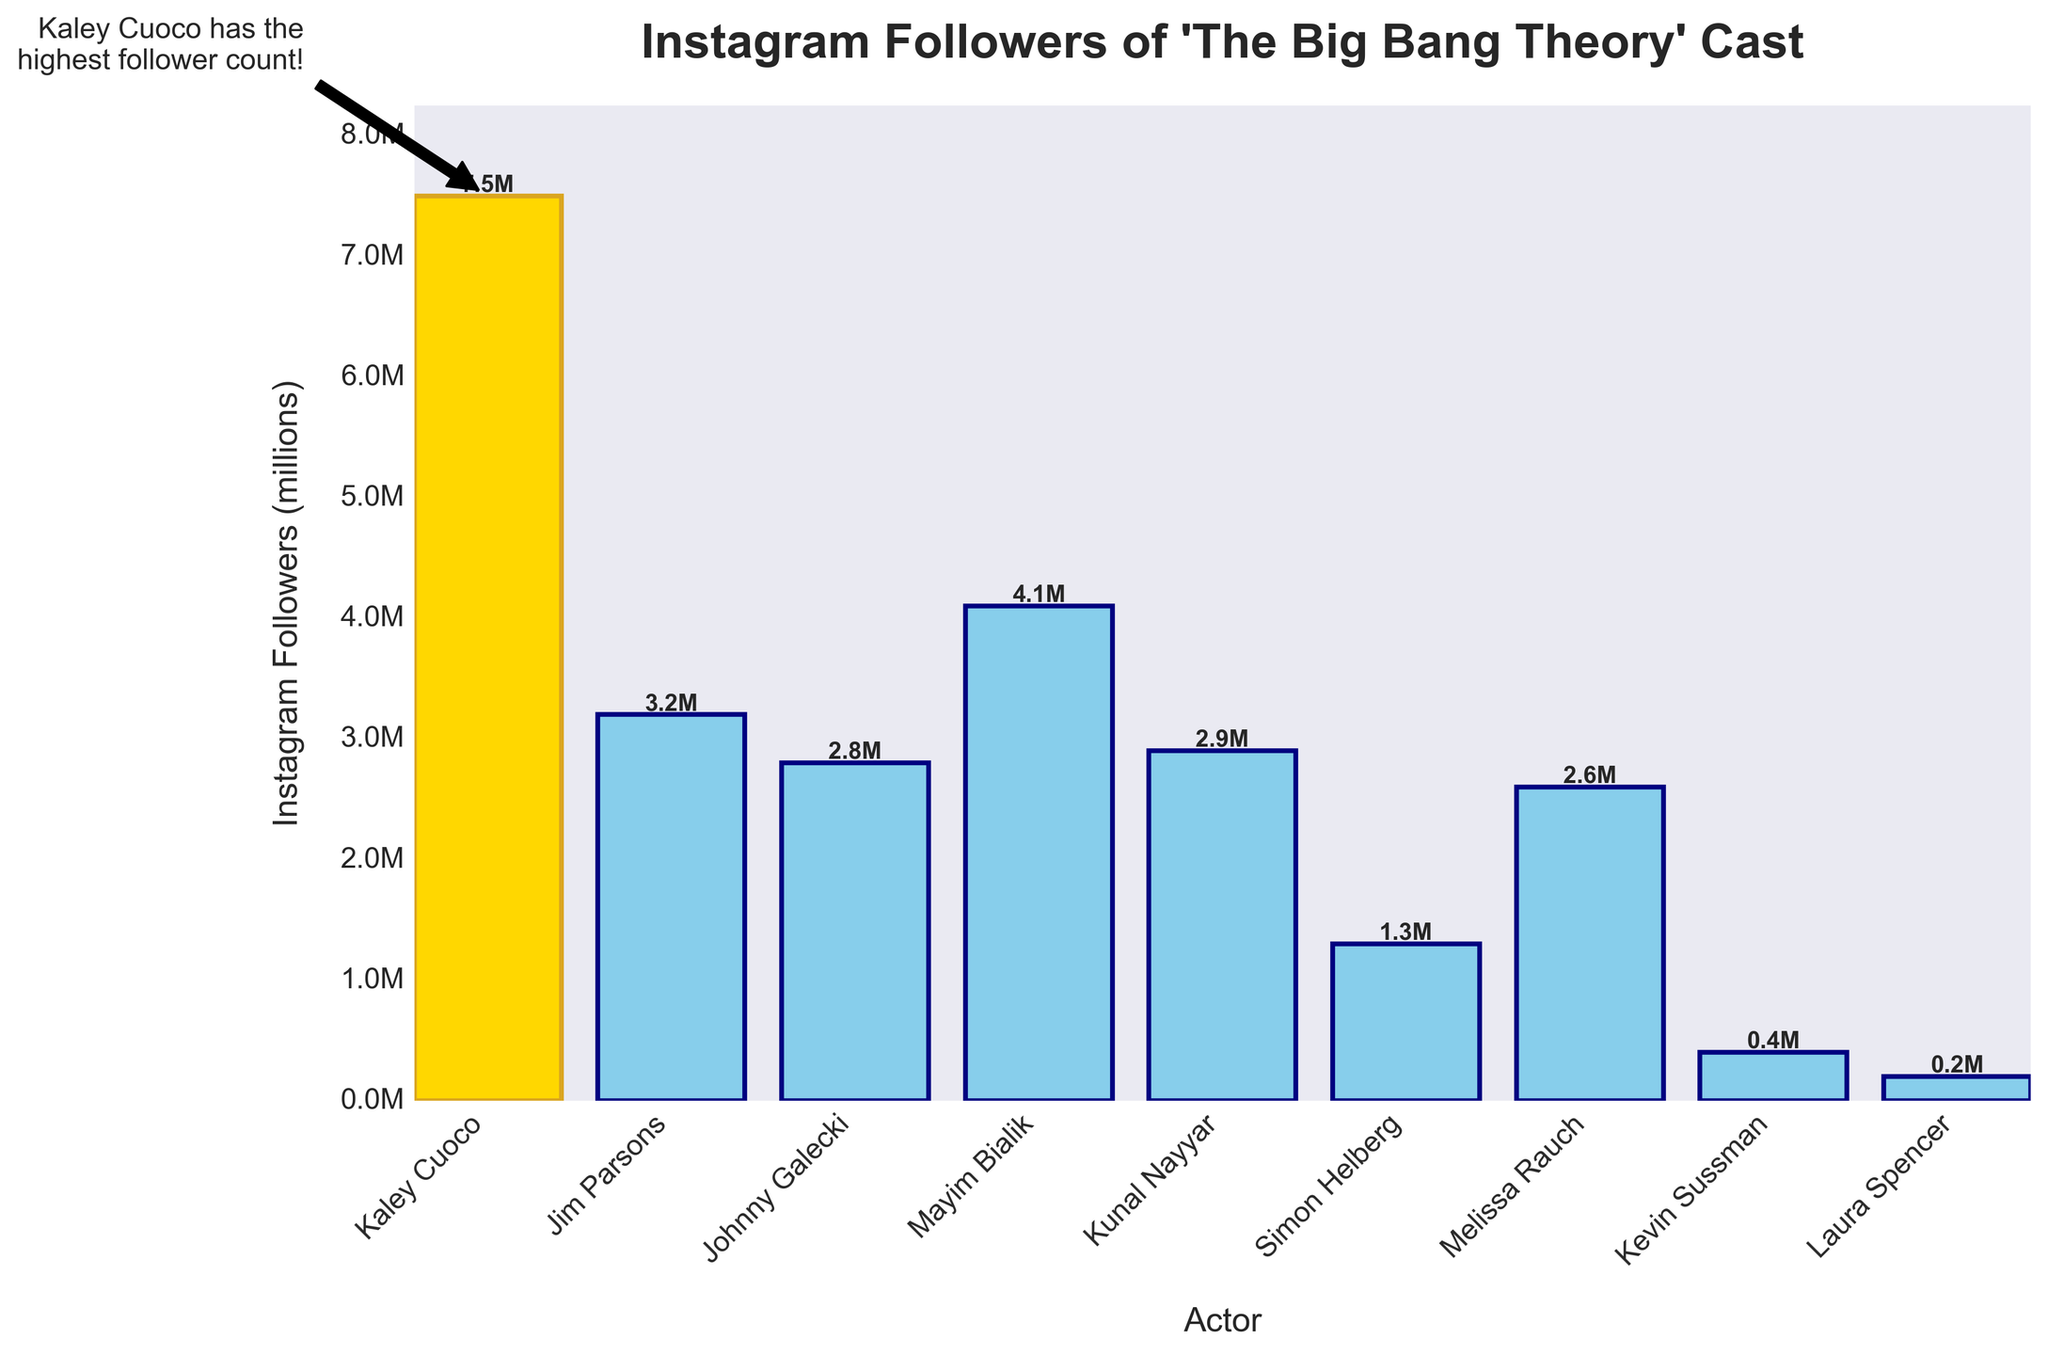Who is the actor with the highest Instagram follower count? Kaley Cuoco's bar is highlighted in gold and annotated with a note stating she has the highest follower count.
Answer: Kaley Cuoco Who has more followers, Jim Parsons or Kunal Nayyar? Jim Parsons has 3.2M followers and Kunal Nayyar has 2.9M followers; 3.2M is greater than 2.9M.
Answer: Jim Parsons What is the total Instagram follower count for Simon Helberg and Melissa Rauch? Simon Helberg has 1.3M followers and Melissa Rauch has 2.6M followers. Adding them together gives 1.3M + 2.6M = 3.9M.
Answer: 3.9M Which actor has fewer Instagram followers, Kevin Sussman or Laura Spencer? Kevin Sussman has 0.4M followers, and Laura Spencer has 0.2M followers; 0.2M is less than 0.4M.
Answer: Laura Spencer What is the median number of Instagram followers among the cast members? Ordering the followers: 0.2M, 0.4M, 1.3M, 2.6M, 2.8M, 2.9M, 3.2M, 4.1M, 7.5M. The median is the middle value: 2.9M.
Answer: 2.9M How much more Instagram followers does Kaley Cuoco have compared to Johnny Galecki? Kaley Cuoco has 7.5M followers, and Johnny Galecki has 2.8M followers. The difference is 7.5M - 2.8M = 4.7M.
Answer: 4.7M What is the average Instagram follower count for all the actors? Summing all followers: 7.5M + 3.2M + 2.8M + 4.1M + 2.9M + 1.3M + 2.6M + 0.4M + 0.2M = 25.0M. The number of actors is 9. The average is 25.0M / 9 ≈ 2.78M.
Answer: 2.78M Who are the actors with Instagram follower counts greater than 3 million? The follower counts greater than 3M are Kaley Cuoco (7.5M), Jim Parsons (3.2M), and Mayim Bialik (4.1M).
Answer: Kaley Cuoco, Jim Parsons, Mayim Bialik Which actors have Instagram follower counts less than 2 million? The follower counts less than 2M are Simon Helberg (1.3M), Kevin Sussman (0.4M), and Laura Spencer (0.2M).
Answer: Simon Helberg, Kevin Sussman, Laura Spencer Between Kaley Cuoco and Mayim Bialik, who has the higher Instagram follower count and by how much? Kaley Cuoco has 7.5M followers and Mayim Bialik has 4.1M followers. The difference is 7.5M - 4.1M = 3.4M.
Answer: Kaley Cuoco by 3.4M 